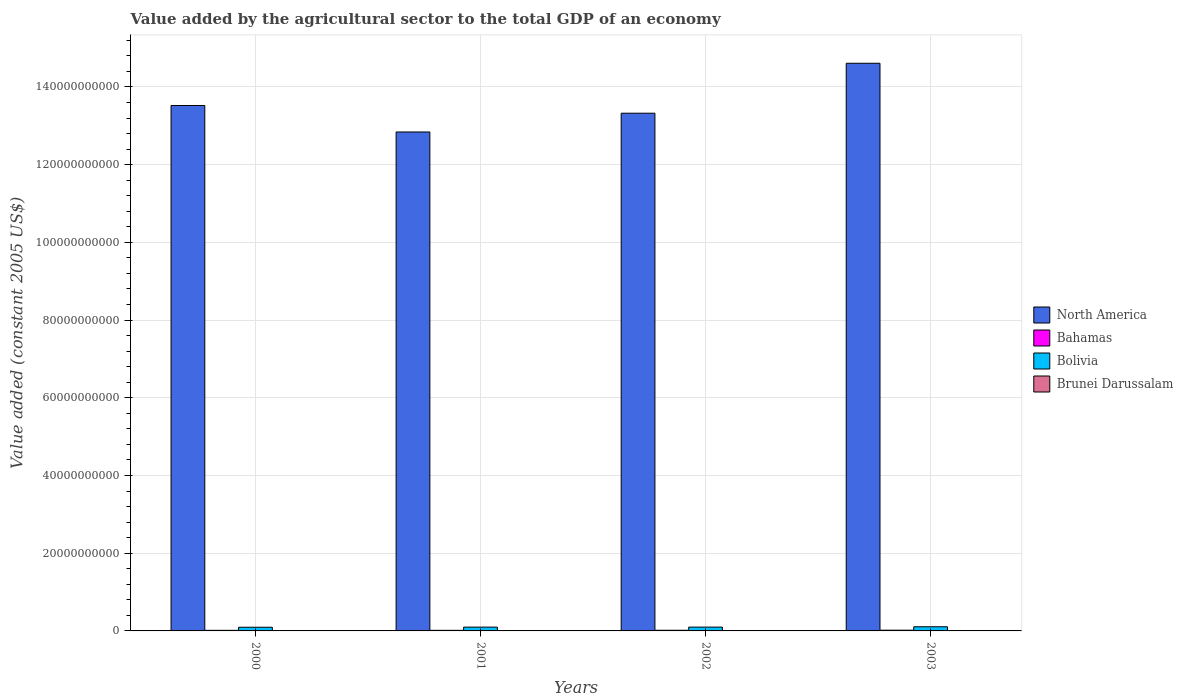How many groups of bars are there?
Your answer should be very brief. 4. Are the number of bars per tick equal to the number of legend labels?
Offer a terse response. Yes. Are the number of bars on each tick of the X-axis equal?
Provide a succinct answer. Yes. How many bars are there on the 1st tick from the right?
Make the answer very short. 4. What is the label of the 4th group of bars from the left?
Offer a very short reply. 2003. In how many cases, is the number of bars for a given year not equal to the number of legend labels?
Offer a terse response. 0. What is the value added by the agricultural sector in North America in 2002?
Provide a succinct answer. 1.33e+11. Across all years, what is the maximum value added by the agricultural sector in Brunei Darussalam?
Your answer should be very brief. 7.95e+07. Across all years, what is the minimum value added by the agricultural sector in North America?
Your answer should be compact. 1.28e+11. In which year was the value added by the agricultural sector in Bolivia maximum?
Your answer should be very brief. 2003. In which year was the value added by the agricultural sector in Bahamas minimum?
Offer a terse response. 2000. What is the total value added by the agricultural sector in Bahamas in the graph?
Ensure brevity in your answer.  6.61e+08. What is the difference between the value added by the agricultural sector in Bahamas in 2000 and that in 2003?
Provide a short and direct response. -3.88e+07. What is the difference between the value added by the agricultural sector in North America in 2001 and the value added by the agricultural sector in Brunei Darussalam in 2002?
Give a very brief answer. 1.28e+11. What is the average value added by the agricultural sector in North America per year?
Make the answer very short. 1.36e+11. In the year 2002, what is the difference between the value added by the agricultural sector in North America and value added by the agricultural sector in Bolivia?
Offer a very short reply. 1.32e+11. What is the ratio of the value added by the agricultural sector in Bolivia in 2000 to that in 2001?
Keep it short and to the point. 0.97. Is the value added by the agricultural sector in Brunei Darussalam in 2000 less than that in 2001?
Your answer should be very brief. Yes. Is the difference between the value added by the agricultural sector in North America in 2000 and 2002 greater than the difference between the value added by the agricultural sector in Bolivia in 2000 and 2002?
Make the answer very short. Yes. What is the difference between the highest and the second highest value added by the agricultural sector in North America?
Offer a terse response. 1.09e+1. What is the difference between the highest and the lowest value added by the agricultural sector in Brunei Darussalam?
Provide a succinct answer. 1.53e+07. Is the sum of the value added by the agricultural sector in Bolivia in 2001 and 2002 greater than the maximum value added by the agricultural sector in Bahamas across all years?
Your response must be concise. Yes. What does the 2nd bar from the left in 2002 represents?
Make the answer very short. Bahamas. What does the 2nd bar from the right in 2000 represents?
Offer a very short reply. Bolivia. How many years are there in the graph?
Ensure brevity in your answer.  4. What is the difference between two consecutive major ticks on the Y-axis?
Make the answer very short. 2.00e+1. Are the values on the major ticks of Y-axis written in scientific E-notation?
Keep it short and to the point. No. Does the graph contain grids?
Your answer should be very brief. Yes. What is the title of the graph?
Offer a terse response. Value added by the agricultural sector to the total GDP of an economy. Does "Colombia" appear as one of the legend labels in the graph?
Provide a succinct answer. No. What is the label or title of the Y-axis?
Your answer should be very brief. Value added (constant 2005 US$). What is the Value added (constant 2005 US$) in North America in 2000?
Give a very brief answer. 1.35e+11. What is the Value added (constant 2005 US$) in Bahamas in 2000?
Ensure brevity in your answer.  1.49e+08. What is the Value added (constant 2005 US$) of Bolivia in 2000?
Your response must be concise. 9.47e+08. What is the Value added (constant 2005 US$) in Brunei Darussalam in 2000?
Provide a short and direct response. 6.42e+07. What is the Value added (constant 2005 US$) of North America in 2001?
Make the answer very short. 1.28e+11. What is the Value added (constant 2005 US$) in Bahamas in 2001?
Your response must be concise. 1.52e+08. What is the Value added (constant 2005 US$) of Bolivia in 2001?
Keep it short and to the point. 9.80e+08. What is the Value added (constant 2005 US$) in Brunei Darussalam in 2001?
Provide a succinct answer. 6.79e+07. What is the Value added (constant 2005 US$) of North America in 2002?
Give a very brief answer. 1.33e+11. What is the Value added (constant 2005 US$) in Bahamas in 2002?
Give a very brief answer. 1.72e+08. What is the Value added (constant 2005 US$) of Bolivia in 2002?
Ensure brevity in your answer.  9.84e+08. What is the Value added (constant 2005 US$) of Brunei Darussalam in 2002?
Make the answer very short. 7.14e+07. What is the Value added (constant 2005 US$) of North America in 2003?
Provide a succinct answer. 1.46e+11. What is the Value added (constant 2005 US$) in Bahamas in 2003?
Offer a very short reply. 1.88e+08. What is the Value added (constant 2005 US$) in Bolivia in 2003?
Keep it short and to the point. 1.07e+09. What is the Value added (constant 2005 US$) of Brunei Darussalam in 2003?
Ensure brevity in your answer.  7.95e+07. Across all years, what is the maximum Value added (constant 2005 US$) in North America?
Offer a very short reply. 1.46e+11. Across all years, what is the maximum Value added (constant 2005 US$) in Bahamas?
Provide a succinct answer. 1.88e+08. Across all years, what is the maximum Value added (constant 2005 US$) of Bolivia?
Your response must be concise. 1.07e+09. Across all years, what is the maximum Value added (constant 2005 US$) in Brunei Darussalam?
Offer a very short reply. 7.95e+07. Across all years, what is the minimum Value added (constant 2005 US$) of North America?
Offer a very short reply. 1.28e+11. Across all years, what is the minimum Value added (constant 2005 US$) of Bahamas?
Keep it short and to the point. 1.49e+08. Across all years, what is the minimum Value added (constant 2005 US$) in Bolivia?
Ensure brevity in your answer.  9.47e+08. Across all years, what is the minimum Value added (constant 2005 US$) in Brunei Darussalam?
Make the answer very short. 6.42e+07. What is the total Value added (constant 2005 US$) in North America in the graph?
Your answer should be compact. 5.43e+11. What is the total Value added (constant 2005 US$) in Bahamas in the graph?
Offer a terse response. 6.61e+08. What is the total Value added (constant 2005 US$) of Bolivia in the graph?
Provide a short and direct response. 3.98e+09. What is the total Value added (constant 2005 US$) of Brunei Darussalam in the graph?
Offer a terse response. 2.83e+08. What is the difference between the Value added (constant 2005 US$) in North America in 2000 and that in 2001?
Make the answer very short. 6.82e+09. What is the difference between the Value added (constant 2005 US$) of Bahamas in 2000 and that in 2001?
Offer a very short reply. -2.44e+06. What is the difference between the Value added (constant 2005 US$) in Bolivia in 2000 and that in 2001?
Provide a succinct answer. -3.28e+07. What is the difference between the Value added (constant 2005 US$) in Brunei Darussalam in 2000 and that in 2001?
Provide a short and direct response. -3.75e+06. What is the difference between the Value added (constant 2005 US$) of North America in 2000 and that in 2002?
Provide a short and direct response. 1.99e+09. What is the difference between the Value added (constant 2005 US$) of Bahamas in 2000 and that in 2002?
Your response must be concise. -2.30e+07. What is the difference between the Value added (constant 2005 US$) in Bolivia in 2000 and that in 2002?
Provide a short and direct response. -3.72e+07. What is the difference between the Value added (constant 2005 US$) in Brunei Darussalam in 2000 and that in 2002?
Your answer should be compact. -7.27e+06. What is the difference between the Value added (constant 2005 US$) of North America in 2000 and that in 2003?
Provide a short and direct response. -1.09e+1. What is the difference between the Value added (constant 2005 US$) of Bahamas in 2000 and that in 2003?
Your answer should be compact. -3.88e+07. What is the difference between the Value added (constant 2005 US$) in Bolivia in 2000 and that in 2003?
Keep it short and to the point. -1.23e+08. What is the difference between the Value added (constant 2005 US$) in Brunei Darussalam in 2000 and that in 2003?
Provide a short and direct response. -1.53e+07. What is the difference between the Value added (constant 2005 US$) of North America in 2001 and that in 2002?
Offer a very short reply. -4.83e+09. What is the difference between the Value added (constant 2005 US$) of Bahamas in 2001 and that in 2002?
Keep it short and to the point. -2.05e+07. What is the difference between the Value added (constant 2005 US$) in Bolivia in 2001 and that in 2002?
Keep it short and to the point. -4.38e+06. What is the difference between the Value added (constant 2005 US$) in Brunei Darussalam in 2001 and that in 2002?
Provide a succinct answer. -3.52e+06. What is the difference between the Value added (constant 2005 US$) in North America in 2001 and that in 2003?
Offer a very short reply. -1.77e+1. What is the difference between the Value added (constant 2005 US$) in Bahamas in 2001 and that in 2003?
Provide a short and direct response. -3.63e+07. What is the difference between the Value added (constant 2005 US$) of Bolivia in 2001 and that in 2003?
Your answer should be very brief. -9.01e+07. What is the difference between the Value added (constant 2005 US$) of Brunei Darussalam in 2001 and that in 2003?
Keep it short and to the point. -1.16e+07. What is the difference between the Value added (constant 2005 US$) of North America in 2002 and that in 2003?
Provide a short and direct response. -1.29e+1. What is the difference between the Value added (constant 2005 US$) in Bahamas in 2002 and that in 2003?
Provide a short and direct response. -1.58e+07. What is the difference between the Value added (constant 2005 US$) in Bolivia in 2002 and that in 2003?
Provide a succinct answer. -8.58e+07. What is the difference between the Value added (constant 2005 US$) of Brunei Darussalam in 2002 and that in 2003?
Offer a very short reply. -8.08e+06. What is the difference between the Value added (constant 2005 US$) in North America in 2000 and the Value added (constant 2005 US$) in Bahamas in 2001?
Provide a succinct answer. 1.35e+11. What is the difference between the Value added (constant 2005 US$) in North America in 2000 and the Value added (constant 2005 US$) in Bolivia in 2001?
Give a very brief answer. 1.34e+11. What is the difference between the Value added (constant 2005 US$) in North America in 2000 and the Value added (constant 2005 US$) in Brunei Darussalam in 2001?
Your answer should be compact. 1.35e+11. What is the difference between the Value added (constant 2005 US$) of Bahamas in 2000 and the Value added (constant 2005 US$) of Bolivia in 2001?
Offer a terse response. -8.31e+08. What is the difference between the Value added (constant 2005 US$) of Bahamas in 2000 and the Value added (constant 2005 US$) of Brunei Darussalam in 2001?
Make the answer very short. 8.13e+07. What is the difference between the Value added (constant 2005 US$) of Bolivia in 2000 and the Value added (constant 2005 US$) of Brunei Darussalam in 2001?
Ensure brevity in your answer.  8.79e+08. What is the difference between the Value added (constant 2005 US$) in North America in 2000 and the Value added (constant 2005 US$) in Bahamas in 2002?
Make the answer very short. 1.35e+11. What is the difference between the Value added (constant 2005 US$) of North America in 2000 and the Value added (constant 2005 US$) of Bolivia in 2002?
Ensure brevity in your answer.  1.34e+11. What is the difference between the Value added (constant 2005 US$) of North America in 2000 and the Value added (constant 2005 US$) of Brunei Darussalam in 2002?
Your answer should be compact. 1.35e+11. What is the difference between the Value added (constant 2005 US$) of Bahamas in 2000 and the Value added (constant 2005 US$) of Bolivia in 2002?
Make the answer very short. -8.35e+08. What is the difference between the Value added (constant 2005 US$) of Bahamas in 2000 and the Value added (constant 2005 US$) of Brunei Darussalam in 2002?
Ensure brevity in your answer.  7.78e+07. What is the difference between the Value added (constant 2005 US$) in Bolivia in 2000 and the Value added (constant 2005 US$) in Brunei Darussalam in 2002?
Keep it short and to the point. 8.76e+08. What is the difference between the Value added (constant 2005 US$) in North America in 2000 and the Value added (constant 2005 US$) in Bahamas in 2003?
Offer a very short reply. 1.35e+11. What is the difference between the Value added (constant 2005 US$) in North America in 2000 and the Value added (constant 2005 US$) in Bolivia in 2003?
Ensure brevity in your answer.  1.34e+11. What is the difference between the Value added (constant 2005 US$) of North America in 2000 and the Value added (constant 2005 US$) of Brunei Darussalam in 2003?
Provide a succinct answer. 1.35e+11. What is the difference between the Value added (constant 2005 US$) of Bahamas in 2000 and the Value added (constant 2005 US$) of Bolivia in 2003?
Provide a short and direct response. -9.21e+08. What is the difference between the Value added (constant 2005 US$) in Bahamas in 2000 and the Value added (constant 2005 US$) in Brunei Darussalam in 2003?
Provide a short and direct response. 6.97e+07. What is the difference between the Value added (constant 2005 US$) of Bolivia in 2000 and the Value added (constant 2005 US$) of Brunei Darussalam in 2003?
Ensure brevity in your answer.  8.68e+08. What is the difference between the Value added (constant 2005 US$) in North America in 2001 and the Value added (constant 2005 US$) in Bahamas in 2002?
Offer a very short reply. 1.28e+11. What is the difference between the Value added (constant 2005 US$) in North America in 2001 and the Value added (constant 2005 US$) in Bolivia in 2002?
Keep it short and to the point. 1.27e+11. What is the difference between the Value added (constant 2005 US$) of North America in 2001 and the Value added (constant 2005 US$) of Brunei Darussalam in 2002?
Your answer should be very brief. 1.28e+11. What is the difference between the Value added (constant 2005 US$) in Bahamas in 2001 and the Value added (constant 2005 US$) in Bolivia in 2002?
Your answer should be compact. -8.33e+08. What is the difference between the Value added (constant 2005 US$) of Bahamas in 2001 and the Value added (constant 2005 US$) of Brunei Darussalam in 2002?
Make the answer very short. 8.02e+07. What is the difference between the Value added (constant 2005 US$) of Bolivia in 2001 and the Value added (constant 2005 US$) of Brunei Darussalam in 2002?
Keep it short and to the point. 9.08e+08. What is the difference between the Value added (constant 2005 US$) of North America in 2001 and the Value added (constant 2005 US$) of Bahamas in 2003?
Keep it short and to the point. 1.28e+11. What is the difference between the Value added (constant 2005 US$) in North America in 2001 and the Value added (constant 2005 US$) in Bolivia in 2003?
Your response must be concise. 1.27e+11. What is the difference between the Value added (constant 2005 US$) in North America in 2001 and the Value added (constant 2005 US$) in Brunei Darussalam in 2003?
Your response must be concise. 1.28e+11. What is the difference between the Value added (constant 2005 US$) of Bahamas in 2001 and the Value added (constant 2005 US$) of Bolivia in 2003?
Keep it short and to the point. -9.18e+08. What is the difference between the Value added (constant 2005 US$) in Bahamas in 2001 and the Value added (constant 2005 US$) in Brunei Darussalam in 2003?
Give a very brief answer. 7.21e+07. What is the difference between the Value added (constant 2005 US$) in Bolivia in 2001 and the Value added (constant 2005 US$) in Brunei Darussalam in 2003?
Your response must be concise. 9.00e+08. What is the difference between the Value added (constant 2005 US$) in North America in 2002 and the Value added (constant 2005 US$) in Bahamas in 2003?
Provide a succinct answer. 1.33e+11. What is the difference between the Value added (constant 2005 US$) in North America in 2002 and the Value added (constant 2005 US$) in Bolivia in 2003?
Provide a short and direct response. 1.32e+11. What is the difference between the Value added (constant 2005 US$) of North America in 2002 and the Value added (constant 2005 US$) of Brunei Darussalam in 2003?
Give a very brief answer. 1.33e+11. What is the difference between the Value added (constant 2005 US$) of Bahamas in 2002 and the Value added (constant 2005 US$) of Bolivia in 2003?
Offer a very short reply. -8.98e+08. What is the difference between the Value added (constant 2005 US$) in Bahamas in 2002 and the Value added (constant 2005 US$) in Brunei Darussalam in 2003?
Your answer should be very brief. 9.27e+07. What is the difference between the Value added (constant 2005 US$) in Bolivia in 2002 and the Value added (constant 2005 US$) in Brunei Darussalam in 2003?
Keep it short and to the point. 9.05e+08. What is the average Value added (constant 2005 US$) of North America per year?
Your response must be concise. 1.36e+11. What is the average Value added (constant 2005 US$) of Bahamas per year?
Your answer should be compact. 1.65e+08. What is the average Value added (constant 2005 US$) in Bolivia per year?
Offer a very short reply. 9.95e+08. What is the average Value added (constant 2005 US$) in Brunei Darussalam per year?
Offer a terse response. 7.08e+07. In the year 2000, what is the difference between the Value added (constant 2005 US$) in North America and Value added (constant 2005 US$) in Bahamas?
Your answer should be very brief. 1.35e+11. In the year 2000, what is the difference between the Value added (constant 2005 US$) of North America and Value added (constant 2005 US$) of Bolivia?
Your answer should be very brief. 1.34e+11. In the year 2000, what is the difference between the Value added (constant 2005 US$) of North America and Value added (constant 2005 US$) of Brunei Darussalam?
Your response must be concise. 1.35e+11. In the year 2000, what is the difference between the Value added (constant 2005 US$) in Bahamas and Value added (constant 2005 US$) in Bolivia?
Keep it short and to the point. -7.98e+08. In the year 2000, what is the difference between the Value added (constant 2005 US$) of Bahamas and Value added (constant 2005 US$) of Brunei Darussalam?
Keep it short and to the point. 8.50e+07. In the year 2000, what is the difference between the Value added (constant 2005 US$) of Bolivia and Value added (constant 2005 US$) of Brunei Darussalam?
Provide a succinct answer. 8.83e+08. In the year 2001, what is the difference between the Value added (constant 2005 US$) in North America and Value added (constant 2005 US$) in Bahamas?
Offer a very short reply. 1.28e+11. In the year 2001, what is the difference between the Value added (constant 2005 US$) of North America and Value added (constant 2005 US$) of Bolivia?
Your answer should be very brief. 1.27e+11. In the year 2001, what is the difference between the Value added (constant 2005 US$) in North America and Value added (constant 2005 US$) in Brunei Darussalam?
Your response must be concise. 1.28e+11. In the year 2001, what is the difference between the Value added (constant 2005 US$) of Bahamas and Value added (constant 2005 US$) of Bolivia?
Your answer should be compact. -8.28e+08. In the year 2001, what is the difference between the Value added (constant 2005 US$) in Bahamas and Value added (constant 2005 US$) in Brunei Darussalam?
Keep it short and to the point. 8.37e+07. In the year 2001, what is the difference between the Value added (constant 2005 US$) in Bolivia and Value added (constant 2005 US$) in Brunei Darussalam?
Offer a very short reply. 9.12e+08. In the year 2002, what is the difference between the Value added (constant 2005 US$) in North America and Value added (constant 2005 US$) in Bahamas?
Your answer should be compact. 1.33e+11. In the year 2002, what is the difference between the Value added (constant 2005 US$) in North America and Value added (constant 2005 US$) in Bolivia?
Ensure brevity in your answer.  1.32e+11. In the year 2002, what is the difference between the Value added (constant 2005 US$) of North America and Value added (constant 2005 US$) of Brunei Darussalam?
Provide a short and direct response. 1.33e+11. In the year 2002, what is the difference between the Value added (constant 2005 US$) in Bahamas and Value added (constant 2005 US$) in Bolivia?
Provide a succinct answer. -8.12e+08. In the year 2002, what is the difference between the Value added (constant 2005 US$) of Bahamas and Value added (constant 2005 US$) of Brunei Darussalam?
Your answer should be compact. 1.01e+08. In the year 2002, what is the difference between the Value added (constant 2005 US$) of Bolivia and Value added (constant 2005 US$) of Brunei Darussalam?
Keep it short and to the point. 9.13e+08. In the year 2003, what is the difference between the Value added (constant 2005 US$) of North America and Value added (constant 2005 US$) of Bahamas?
Make the answer very short. 1.46e+11. In the year 2003, what is the difference between the Value added (constant 2005 US$) of North America and Value added (constant 2005 US$) of Bolivia?
Offer a terse response. 1.45e+11. In the year 2003, what is the difference between the Value added (constant 2005 US$) in North America and Value added (constant 2005 US$) in Brunei Darussalam?
Ensure brevity in your answer.  1.46e+11. In the year 2003, what is the difference between the Value added (constant 2005 US$) of Bahamas and Value added (constant 2005 US$) of Bolivia?
Provide a short and direct response. -8.82e+08. In the year 2003, what is the difference between the Value added (constant 2005 US$) in Bahamas and Value added (constant 2005 US$) in Brunei Darussalam?
Ensure brevity in your answer.  1.08e+08. In the year 2003, what is the difference between the Value added (constant 2005 US$) in Bolivia and Value added (constant 2005 US$) in Brunei Darussalam?
Provide a short and direct response. 9.90e+08. What is the ratio of the Value added (constant 2005 US$) in North America in 2000 to that in 2001?
Ensure brevity in your answer.  1.05. What is the ratio of the Value added (constant 2005 US$) in Bahamas in 2000 to that in 2001?
Your response must be concise. 0.98. What is the ratio of the Value added (constant 2005 US$) in Bolivia in 2000 to that in 2001?
Offer a terse response. 0.97. What is the ratio of the Value added (constant 2005 US$) in Brunei Darussalam in 2000 to that in 2001?
Offer a terse response. 0.94. What is the ratio of the Value added (constant 2005 US$) of North America in 2000 to that in 2002?
Ensure brevity in your answer.  1.01. What is the ratio of the Value added (constant 2005 US$) in Bahamas in 2000 to that in 2002?
Your answer should be very brief. 0.87. What is the ratio of the Value added (constant 2005 US$) in Bolivia in 2000 to that in 2002?
Your answer should be very brief. 0.96. What is the ratio of the Value added (constant 2005 US$) in Brunei Darussalam in 2000 to that in 2002?
Make the answer very short. 0.9. What is the ratio of the Value added (constant 2005 US$) in North America in 2000 to that in 2003?
Offer a very short reply. 0.93. What is the ratio of the Value added (constant 2005 US$) of Bahamas in 2000 to that in 2003?
Keep it short and to the point. 0.79. What is the ratio of the Value added (constant 2005 US$) of Bolivia in 2000 to that in 2003?
Give a very brief answer. 0.89. What is the ratio of the Value added (constant 2005 US$) of Brunei Darussalam in 2000 to that in 2003?
Make the answer very short. 0.81. What is the ratio of the Value added (constant 2005 US$) of North America in 2001 to that in 2002?
Offer a very short reply. 0.96. What is the ratio of the Value added (constant 2005 US$) in Bahamas in 2001 to that in 2002?
Keep it short and to the point. 0.88. What is the ratio of the Value added (constant 2005 US$) in Brunei Darussalam in 2001 to that in 2002?
Keep it short and to the point. 0.95. What is the ratio of the Value added (constant 2005 US$) in North America in 2001 to that in 2003?
Keep it short and to the point. 0.88. What is the ratio of the Value added (constant 2005 US$) in Bahamas in 2001 to that in 2003?
Provide a succinct answer. 0.81. What is the ratio of the Value added (constant 2005 US$) of Bolivia in 2001 to that in 2003?
Keep it short and to the point. 0.92. What is the ratio of the Value added (constant 2005 US$) in Brunei Darussalam in 2001 to that in 2003?
Provide a succinct answer. 0.85. What is the ratio of the Value added (constant 2005 US$) in North America in 2002 to that in 2003?
Your response must be concise. 0.91. What is the ratio of the Value added (constant 2005 US$) in Bahamas in 2002 to that in 2003?
Offer a very short reply. 0.92. What is the ratio of the Value added (constant 2005 US$) of Bolivia in 2002 to that in 2003?
Make the answer very short. 0.92. What is the ratio of the Value added (constant 2005 US$) in Brunei Darussalam in 2002 to that in 2003?
Offer a terse response. 0.9. What is the difference between the highest and the second highest Value added (constant 2005 US$) of North America?
Your response must be concise. 1.09e+1. What is the difference between the highest and the second highest Value added (constant 2005 US$) of Bahamas?
Give a very brief answer. 1.58e+07. What is the difference between the highest and the second highest Value added (constant 2005 US$) in Bolivia?
Provide a succinct answer. 8.58e+07. What is the difference between the highest and the second highest Value added (constant 2005 US$) in Brunei Darussalam?
Keep it short and to the point. 8.08e+06. What is the difference between the highest and the lowest Value added (constant 2005 US$) in North America?
Offer a very short reply. 1.77e+1. What is the difference between the highest and the lowest Value added (constant 2005 US$) of Bahamas?
Make the answer very short. 3.88e+07. What is the difference between the highest and the lowest Value added (constant 2005 US$) of Bolivia?
Offer a terse response. 1.23e+08. What is the difference between the highest and the lowest Value added (constant 2005 US$) of Brunei Darussalam?
Give a very brief answer. 1.53e+07. 